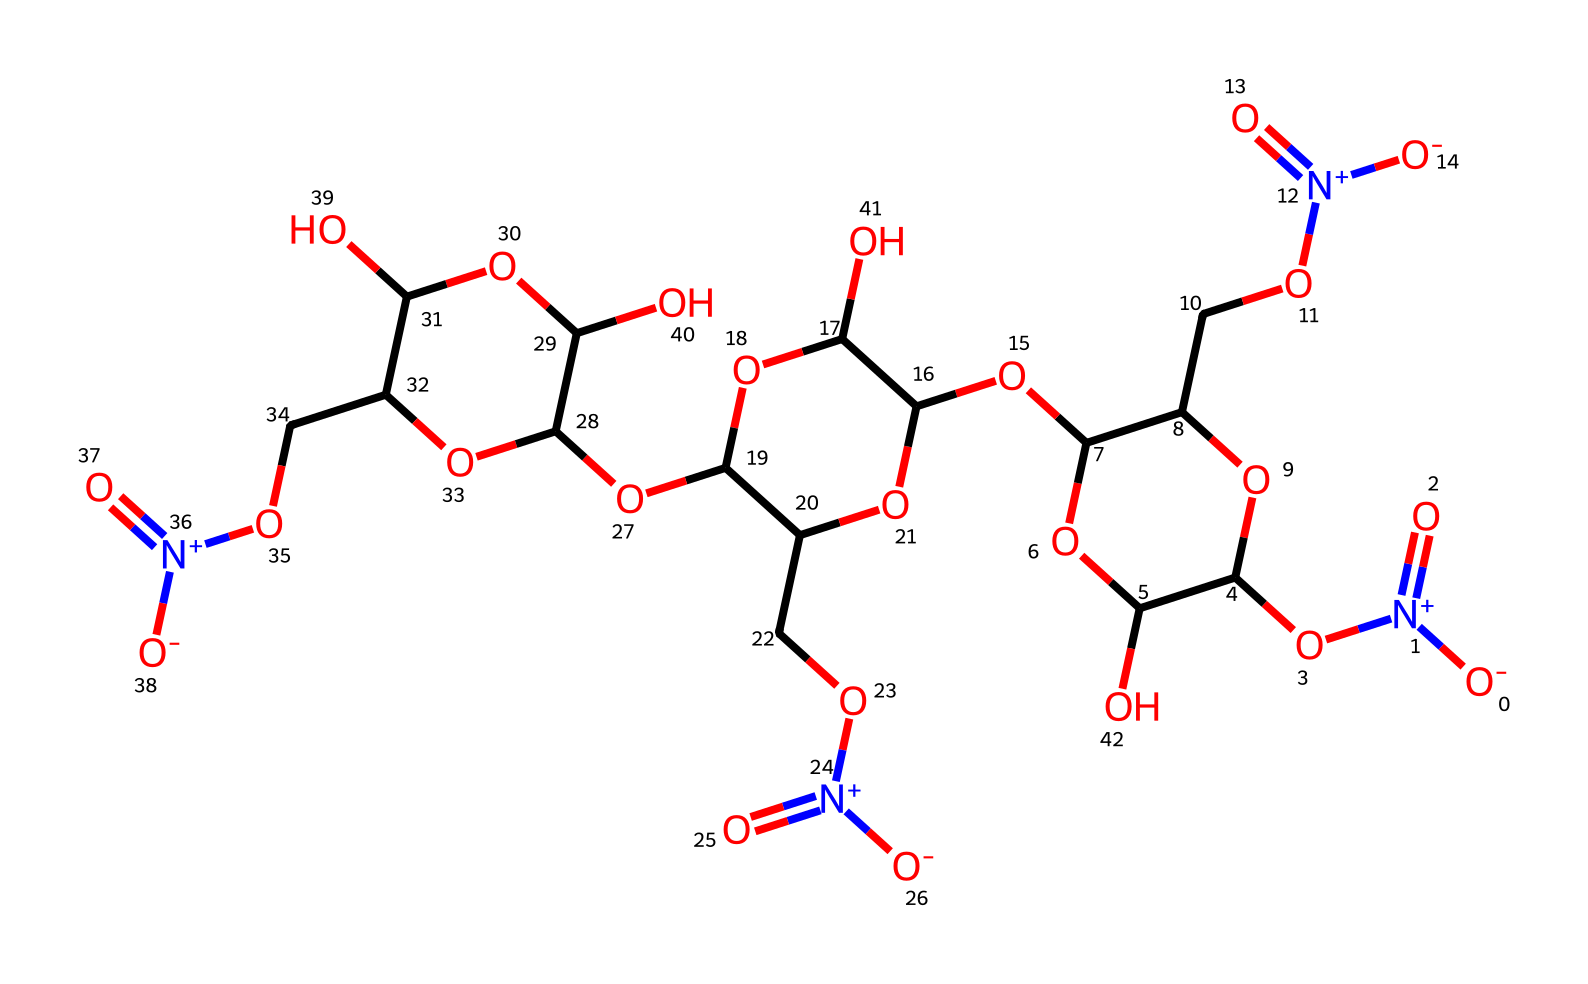What is the main functional group present in this polymer? The chemical structure contains multiple instances of the hydroxyl functional group (-OH) along with nitro groups (-NO2) which suggest functionalities such as potential hydrophilicity and reactivity. The predominant functional groups observed are hydroxyl and nitro groups.
Answer: hydroxyl and nitro How many nitrogen atoms are in this polymer? By analyzing the provided SMILES representation, we can identify three nitrogen atoms that appear as part of the nitro groups present in the structure. Each nitrogen can be counted directly from the SMILES string.
Answer: 3 What is the average connectivity of carbon atoms in this polymer? The polymer contains multiple interconnected sugar-like carbon rings (C), with branching and hydroxyl groups contributing to the structure. Counting the carbon atoms shows that they are involved in a network, indicating a high connectivity based on the cyclic structure.
Answer: high What type of polymer is represented by this chemical structure? This structure suggests that the polymer is a polysaccharide due to the multiple repeating units of sugar-like derivatives connected through ether and hydroxyl linkages, which are characteristic of polysaccharides.
Answer: polysaccharide What is the potential property of this polymer due to the presence of multiple hydroxyl groups? The high number of hydroxyl groups indicates that this polymer would exhibit high hydrophilicity, making it more soluble in water and contributing to its affinity for moisture, which is vital in varnish applications.
Answer: hydrophilicity How does the presence of nitro groups affect the properties of this polymer? Nitro groups introduce polarity and potential oxidative properties to the polymer, which can enhance its adhesive qualities and UV resistance, important for protective coatings like varnish on wooden furnishings.
Answer: enhances adhesive qualities 